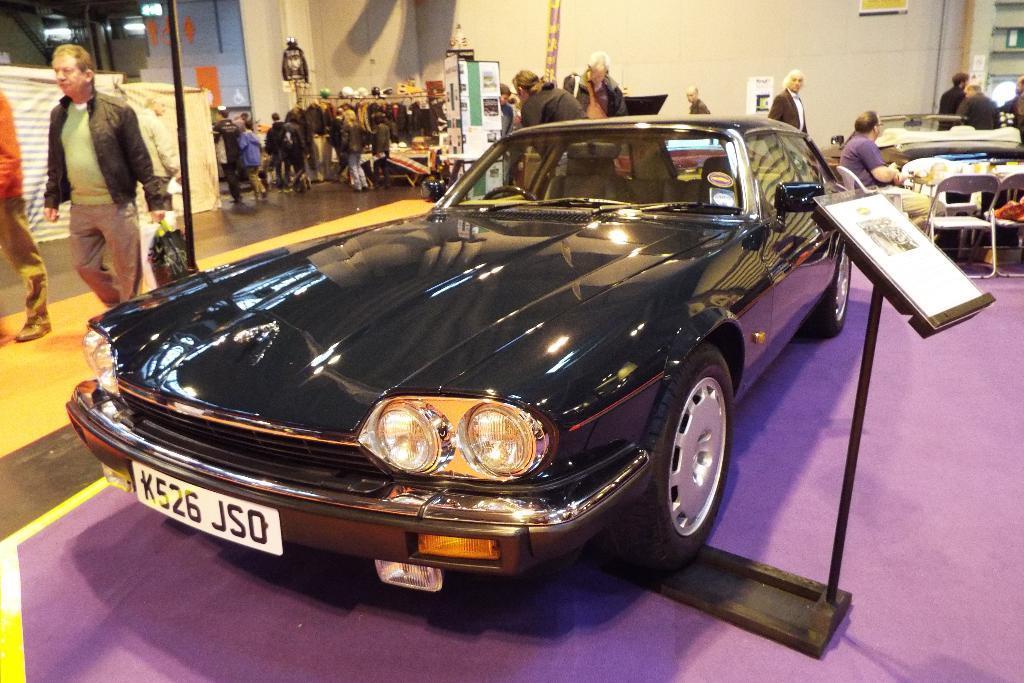How would you summarize this image in a sentence or two? In this image I can see the vehicle in black color. Background I can see few persons, some are standing and some are sitting. In front I can see the board attached to the pole and I can also see few lights and the wall is in cream color. 